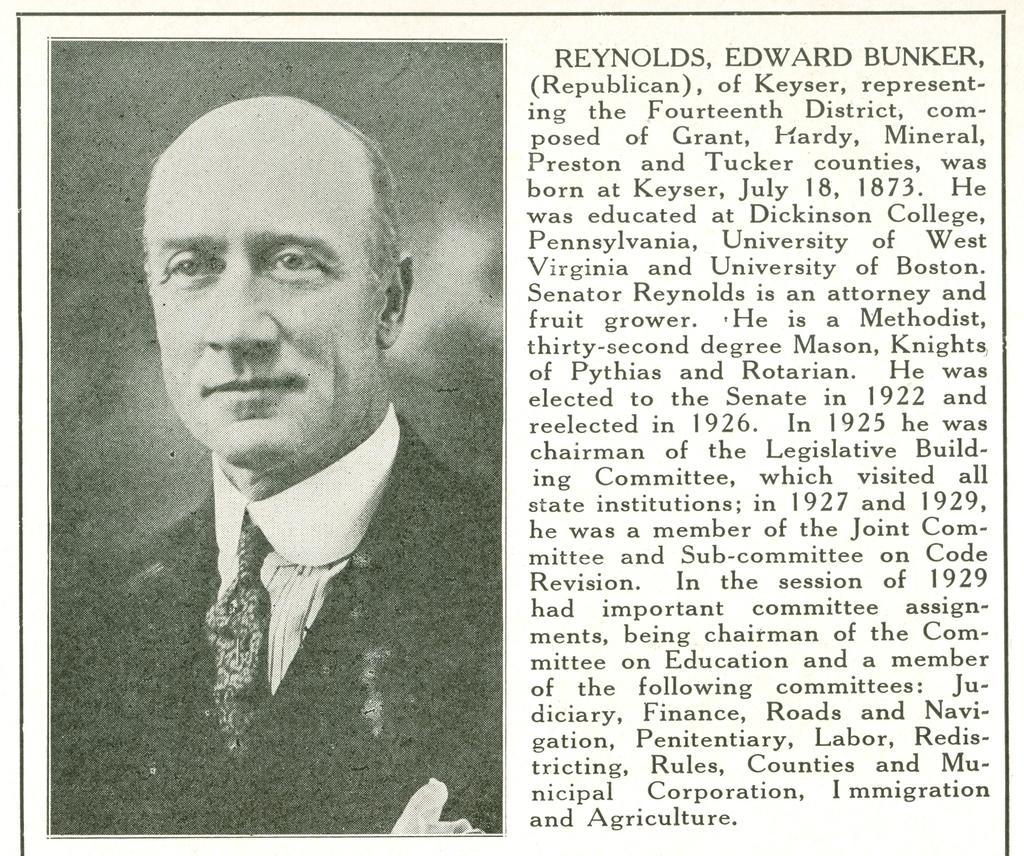Could you give a brief overview of what you see in this image? In this picture there is a person wearing suit in the left corner and there is something written beside it in the right corner. 